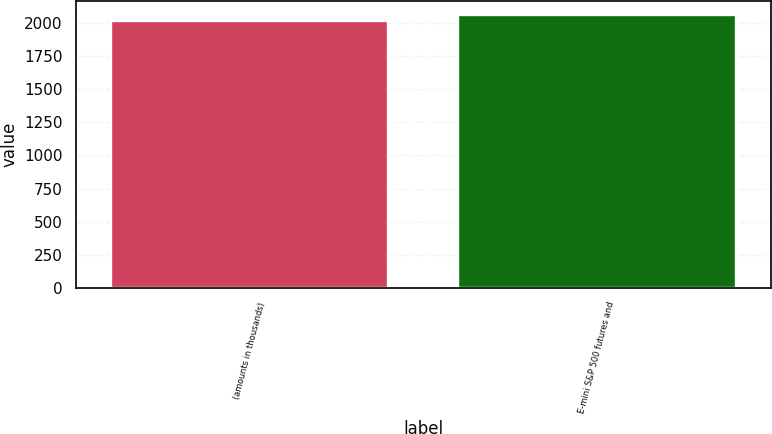<chart> <loc_0><loc_0><loc_500><loc_500><bar_chart><fcel>(amounts in thousands)<fcel>E-mini S&P 500 futures and<nl><fcel>2017<fcel>2062<nl></chart> 